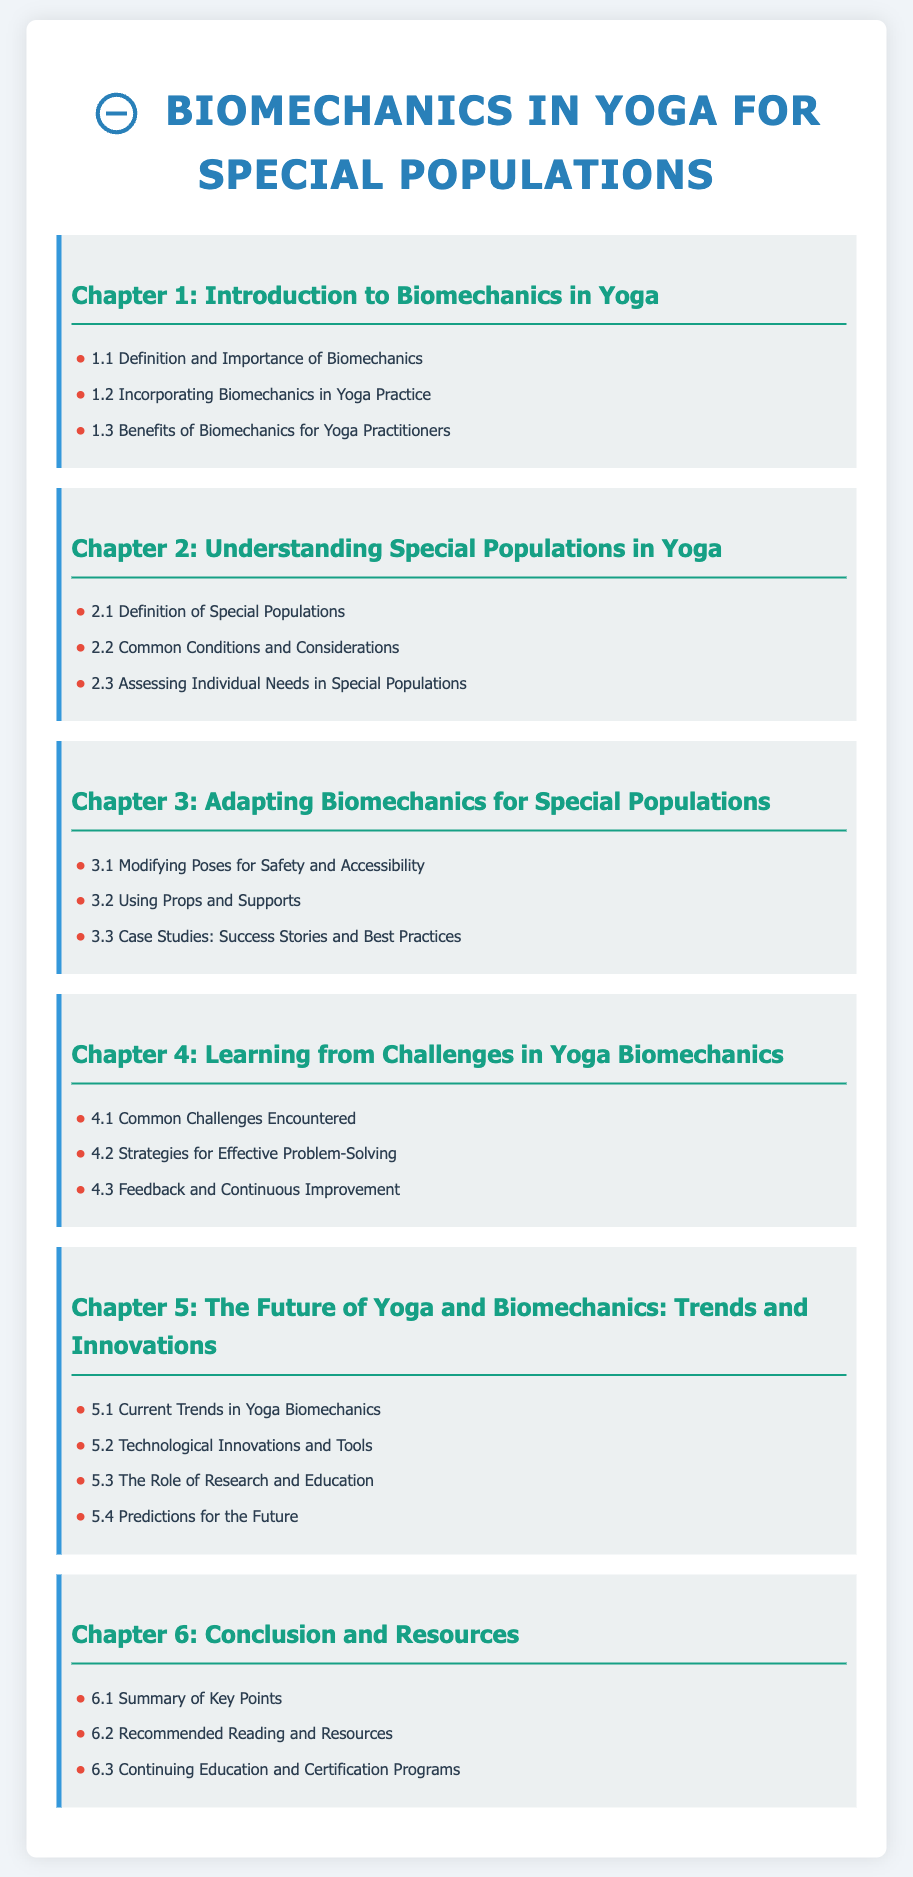what is the title of Chapter 5? The title of Chapter 5 is explicitly stated in the table of contents.
Answer: The Future of Yoga and Biomechanics: Trends and Innovations how many sections are there in Chapter 5? The number of sections can be found by counting the bullet points listed under Chapter 5.
Answer: 4 what is the focus of section 5.2? The focus of section 5.2 is defined in its title under Chapter 5.
Answer: Technological Innovations and Tools which chapter addresses common challenges encountered in yoga biomechanics? The chapter focusing on challenges is specified in the table of contents.
Answer: Chapter 4 what is the last section of the document? The last section is found at the end of the conclusion chapter, as outlined in the table of contents.
Answer: Continuing Education and Certification Programs what is a key theme in Chapter 4? The key theme of Chapter 4 is indicated by its title and subsequent sections.
Answer: Learning from Challenges what type of resource is recommended in Chapter 6.2? The type of resource recommended is clearly stated under Chapter 6.
Answer: Recommended Reading and Resources what is discussed in section 5.3? The content of section 5.3 can be found in its specific title listed under Chapter 5.
Answer: The Role of Research and Education 